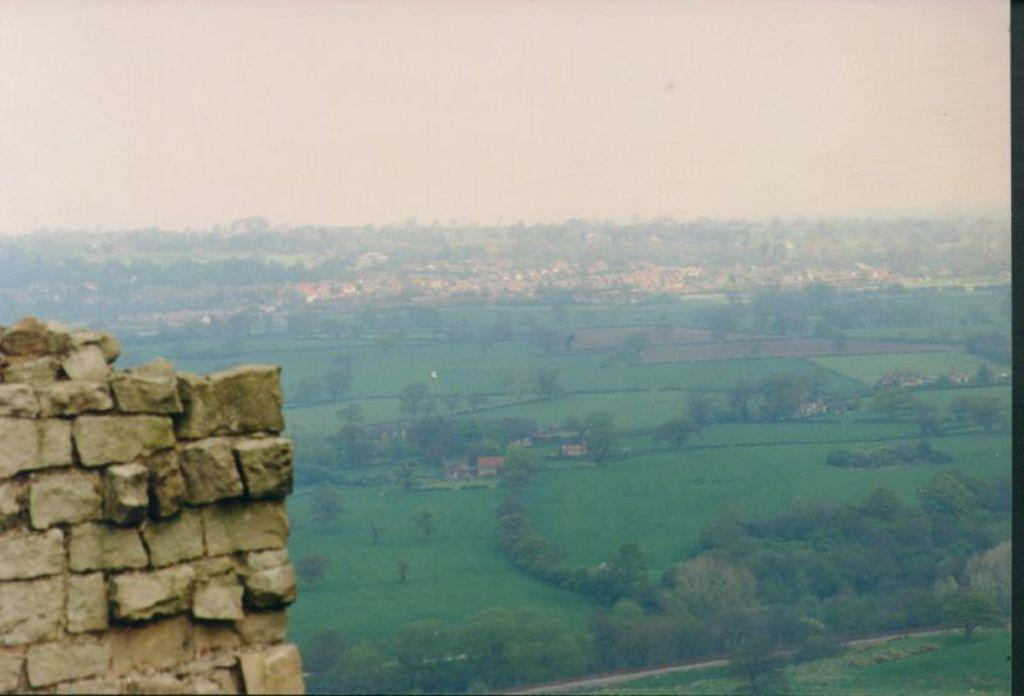What type of structure is on the left side of the image? There is a brick wall on the left side of the image. What can be seen in the background of the image? There are trees and the sky visible in the background of the image. How much profit does the man make from the bike in the image? There is no man or bike present in the image, so it is not possible to determine any profit. 